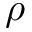Convert formula to latex. <formula><loc_0><loc_0><loc_500><loc_500>\rho</formula> 